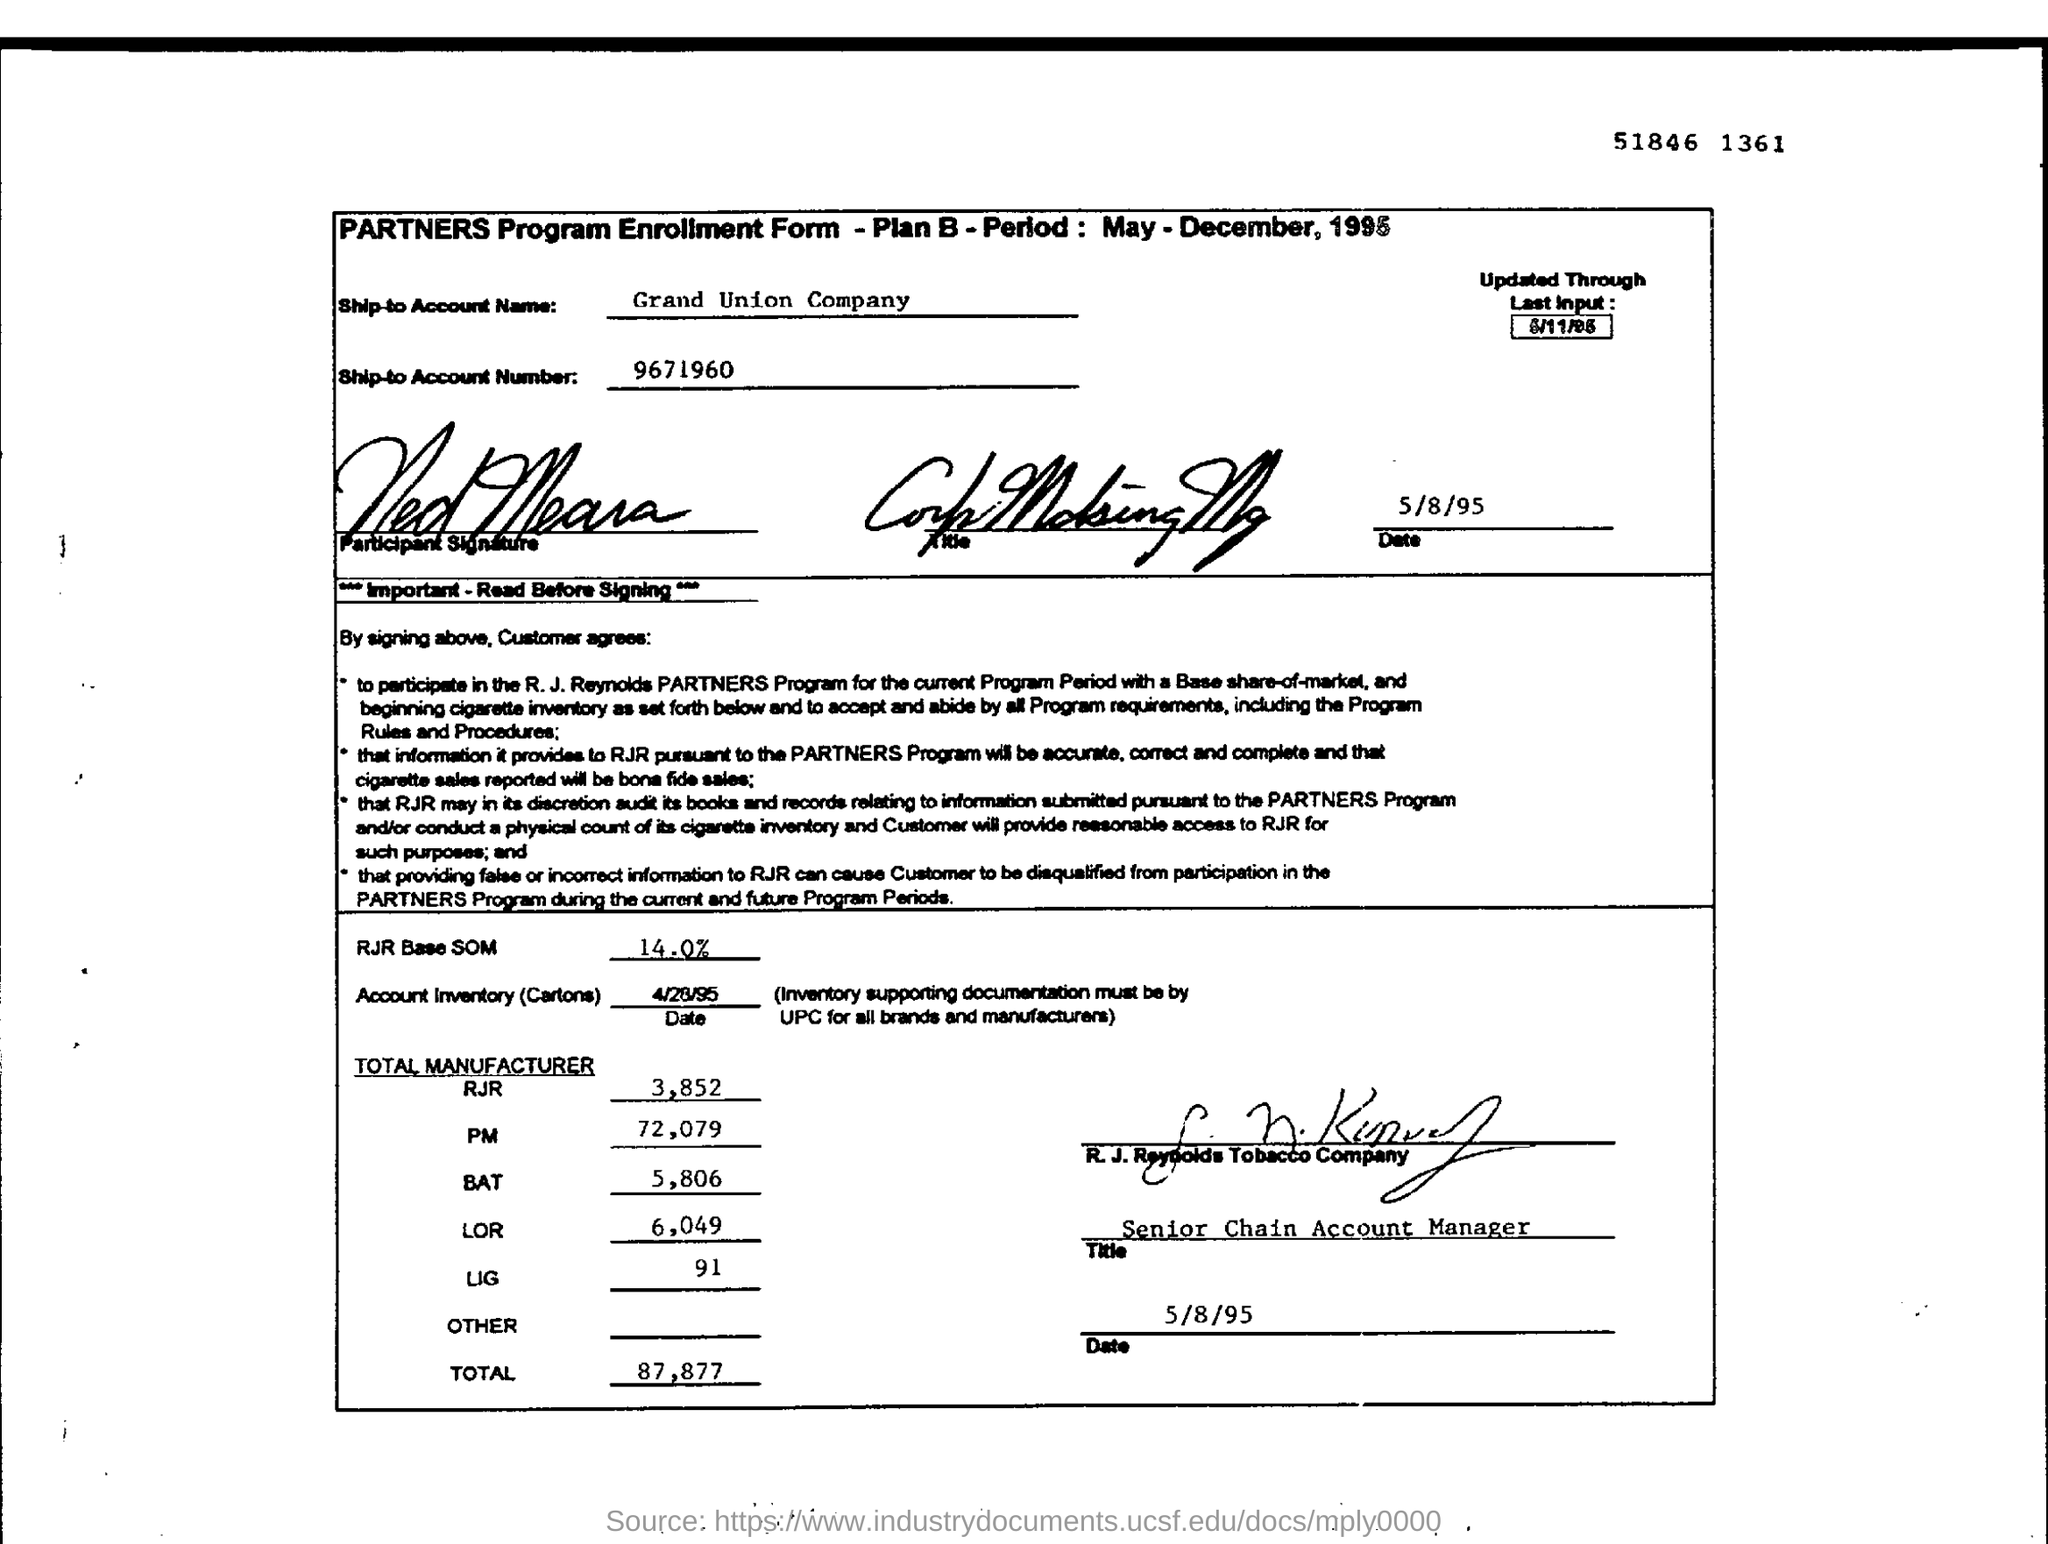Identify some key points in this picture. The total for the manufacturer "LOR" is 6,049. The ship-to account name is Grand Union Company. The total for the manufacturer 'LIG' is 91. The total for the manufacturer 'PM' is 72,079. The total amount for the manufacturer "BAT" is 5,806. 